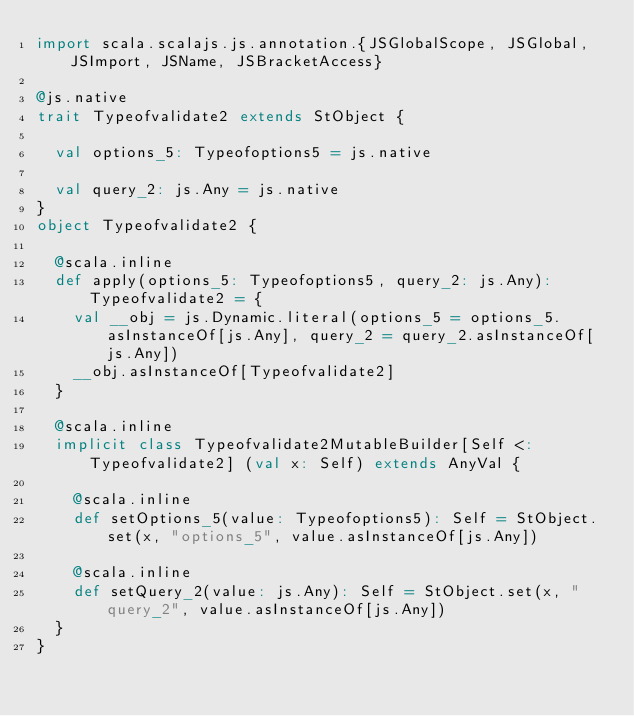<code> <loc_0><loc_0><loc_500><loc_500><_Scala_>import scala.scalajs.js.annotation.{JSGlobalScope, JSGlobal, JSImport, JSName, JSBracketAccess}

@js.native
trait Typeofvalidate2 extends StObject {
  
  val options_5: Typeofoptions5 = js.native
  
  val query_2: js.Any = js.native
}
object Typeofvalidate2 {
  
  @scala.inline
  def apply(options_5: Typeofoptions5, query_2: js.Any): Typeofvalidate2 = {
    val __obj = js.Dynamic.literal(options_5 = options_5.asInstanceOf[js.Any], query_2 = query_2.asInstanceOf[js.Any])
    __obj.asInstanceOf[Typeofvalidate2]
  }
  
  @scala.inline
  implicit class Typeofvalidate2MutableBuilder[Self <: Typeofvalidate2] (val x: Self) extends AnyVal {
    
    @scala.inline
    def setOptions_5(value: Typeofoptions5): Self = StObject.set(x, "options_5", value.asInstanceOf[js.Any])
    
    @scala.inline
    def setQuery_2(value: js.Any): Self = StObject.set(x, "query_2", value.asInstanceOf[js.Any])
  }
}
</code> 